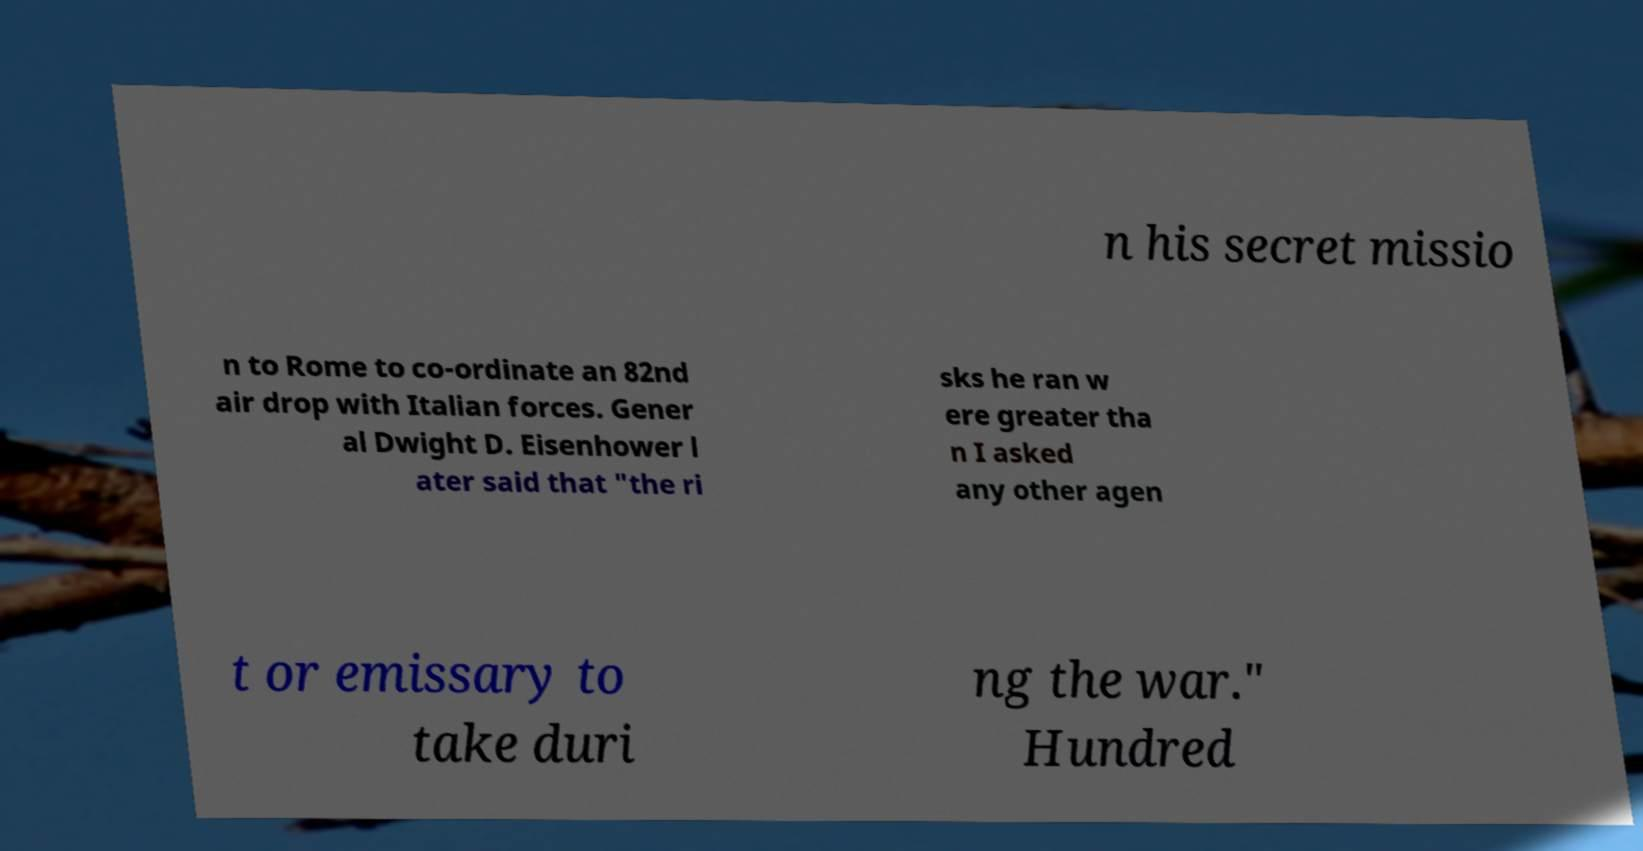I need the written content from this picture converted into text. Can you do that? n his secret missio n to Rome to co-ordinate an 82nd air drop with Italian forces. Gener al Dwight D. Eisenhower l ater said that "the ri sks he ran w ere greater tha n I asked any other agen t or emissary to take duri ng the war." Hundred 